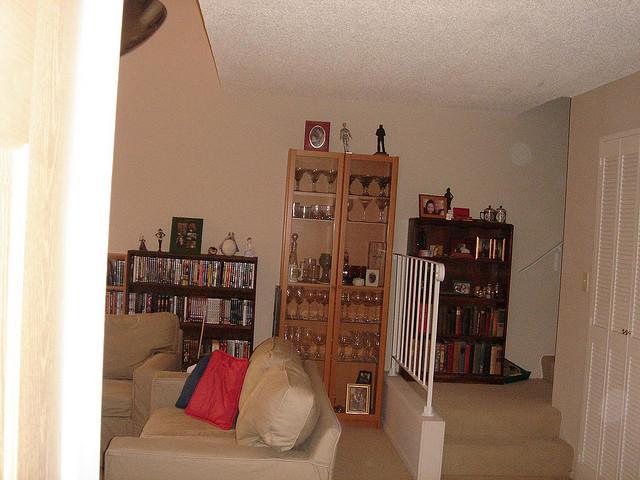Does this room have any stairs?
Quick response, please. Yes. What color is her pillow?
Answer briefly. Red. How many pillows do you see?
Write a very short answer. 2. Is the shelf to the left full?
Keep it brief. Yes. 